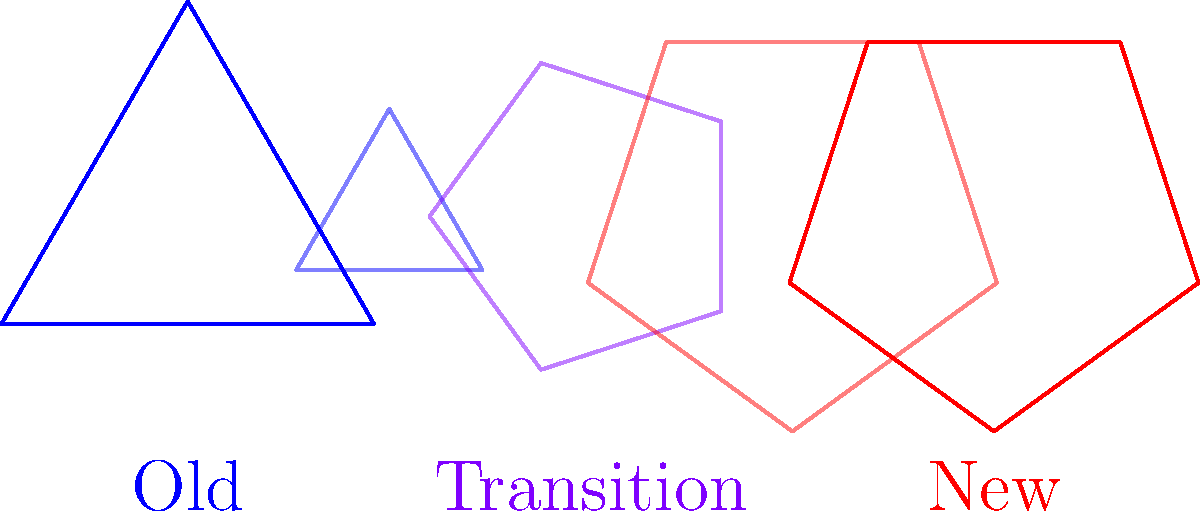In the diagram, geometric shapes represent the evolution of research methodologies. If the blue triangle on the left represents traditional research methods, and the red pentagon on the right represents novel approaches, what does the purple shape in the middle symbolize? How many sides does it have? To answer this question, we need to analyze the diagram step-by-step:

1. The blue triangle on the left represents traditional research methods.
2. The red pentagon on the right represents novel research approaches.
3. The shapes in between show a transition from the old to the new methodology.
4. The middle shape is colored purple, which is a mix of blue (old) and red (new), suggesting a transitional state.
5. Looking closely at the purple shape, we can see it has more sides than the triangle but fewer than the pentagon.
6. Counting the sides of the purple shape reveals that it has 4 sides.

The purple quadrilateral in the middle thus symbolizes a transitional phase between traditional and novel research methodologies, incorporating elements of both approaches. This representation aligns with the gradual evolution of research paradigms, where new methods are often built upon or integrated with existing ones before fully transitioning to novel approaches.
Answer: Transition phase; 4 sides 